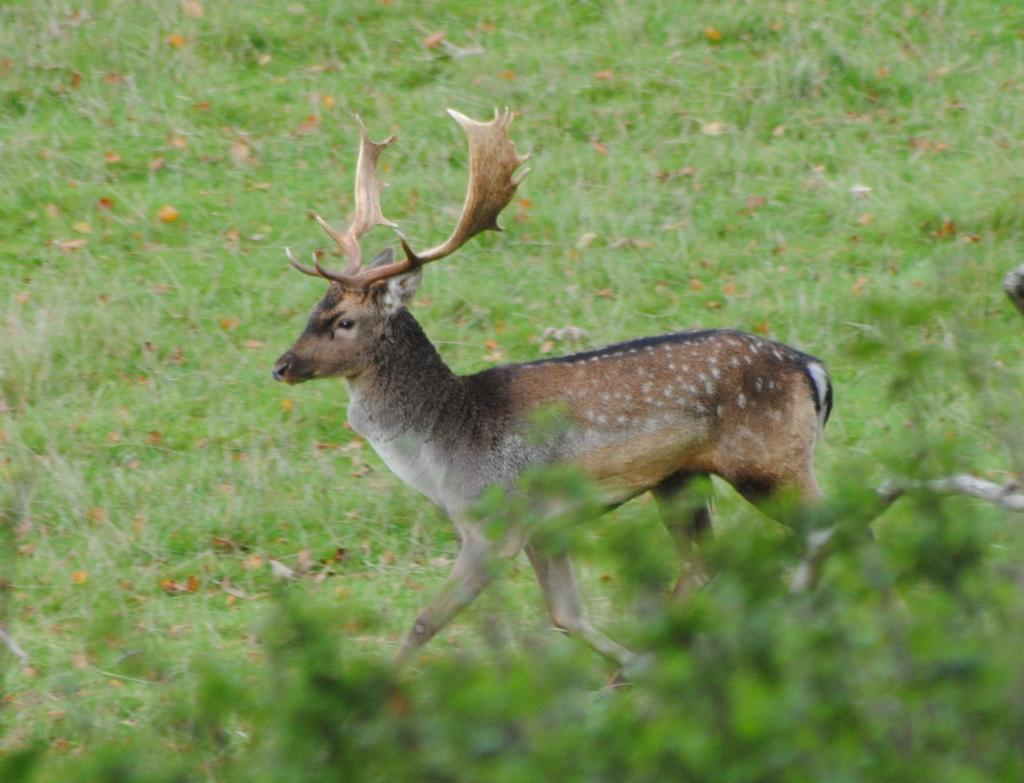What animal is present in the image? There is a deer in the image. Where is the deer located? The deer is in a field. What can be seen in the bottom right corner of the image? There is a plant in the bottom right corner of the image. What type of flooring can be seen in the image? There is no flooring present in the image, as it features a deer in a field. 